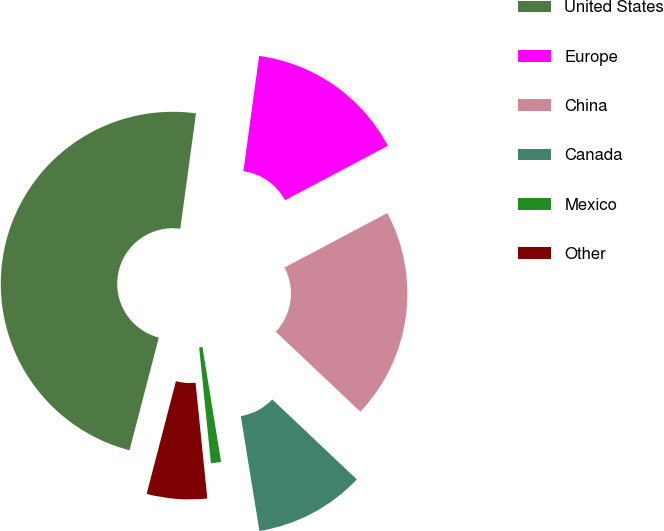Convert chart. <chart><loc_0><loc_0><loc_500><loc_500><pie_chart><fcel>United States<fcel>Europe<fcel>China<fcel>Canada<fcel>Mexico<fcel>Other<nl><fcel>48.11%<fcel>15.09%<fcel>19.81%<fcel>10.38%<fcel>0.95%<fcel>5.66%<nl></chart> 